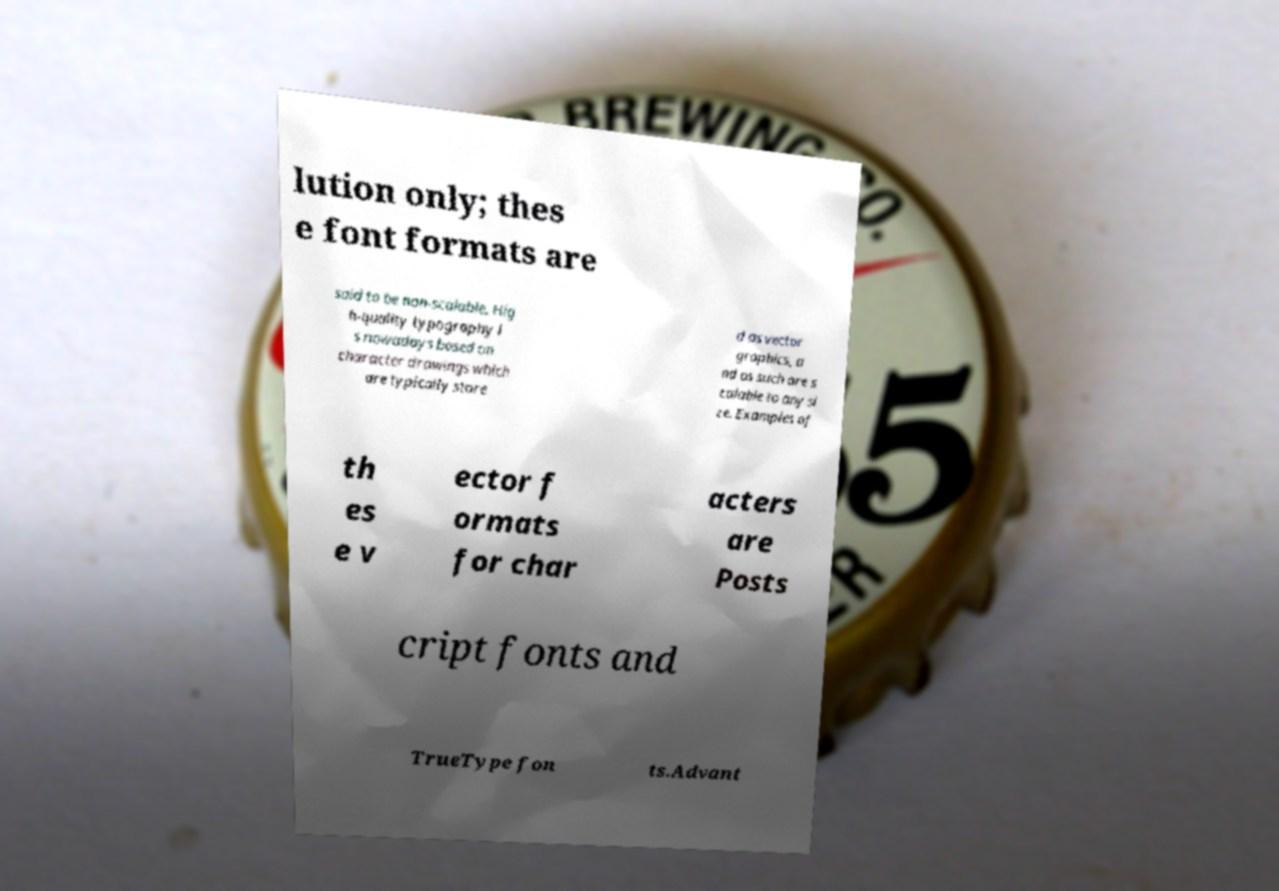For documentation purposes, I need the text within this image transcribed. Could you provide that? lution only; thes e font formats are said to be non-scalable. Hig h-quality typography i s nowadays based on character drawings which are typically store d as vector graphics, a nd as such are s calable to any si ze. Examples of th es e v ector f ormats for char acters are Posts cript fonts and TrueType fon ts.Advant 